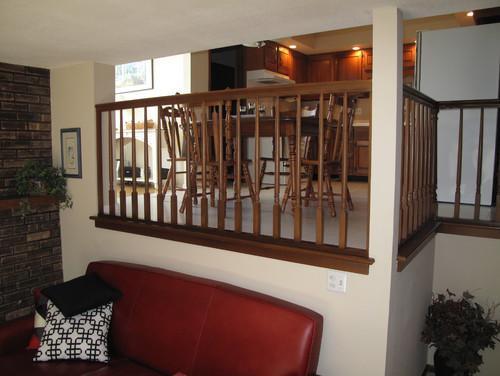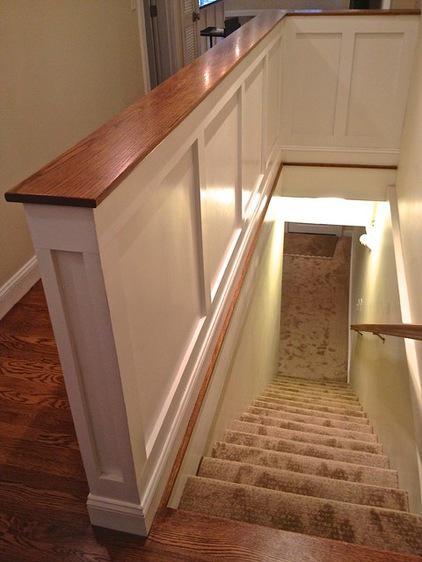The first image is the image on the left, the second image is the image on the right. Analyze the images presented: Is the assertion "An image shows a view down a staircase that leads to a door shape, and a flat ledge is at the left instead of a flight of stairs." valid? Answer yes or no. Yes. 